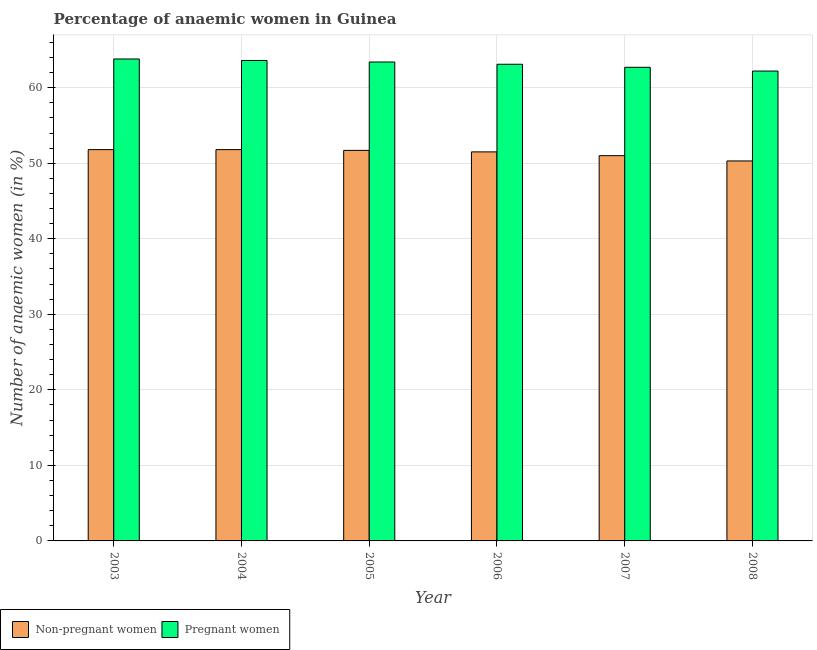Are the number of bars on each tick of the X-axis equal?
Offer a very short reply. Yes. What is the label of the 3rd group of bars from the left?
Keep it short and to the point. 2005. What is the percentage of non-pregnant anaemic women in 2004?
Keep it short and to the point. 51.8. Across all years, what is the maximum percentage of pregnant anaemic women?
Your answer should be very brief. 63.8. Across all years, what is the minimum percentage of non-pregnant anaemic women?
Offer a terse response. 50.3. In which year was the percentage of pregnant anaemic women minimum?
Your answer should be compact. 2008. What is the total percentage of pregnant anaemic women in the graph?
Make the answer very short. 378.8. What is the difference between the percentage of non-pregnant anaemic women in 2004 and that in 2006?
Keep it short and to the point. 0.3. What is the difference between the percentage of non-pregnant anaemic women in 2005 and the percentage of pregnant anaemic women in 2008?
Provide a succinct answer. 1.4. What is the average percentage of non-pregnant anaemic women per year?
Make the answer very short. 51.35. In the year 2006, what is the difference between the percentage of non-pregnant anaemic women and percentage of pregnant anaemic women?
Provide a succinct answer. 0. What is the ratio of the percentage of non-pregnant anaemic women in 2007 to that in 2008?
Your answer should be very brief. 1.01. What is the difference between the highest and the second highest percentage of non-pregnant anaemic women?
Offer a very short reply. 0. What is the difference between the highest and the lowest percentage of non-pregnant anaemic women?
Offer a very short reply. 1.5. What does the 2nd bar from the left in 2007 represents?
Your response must be concise. Pregnant women. What does the 1st bar from the right in 2005 represents?
Ensure brevity in your answer.  Pregnant women. Are all the bars in the graph horizontal?
Provide a short and direct response. No. How many years are there in the graph?
Offer a terse response. 6. What is the difference between two consecutive major ticks on the Y-axis?
Offer a terse response. 10. Does the graph contain grids?
Ensure brevity in your answer.  Yes. Where does the legend appear in the graph?
Give a very brief answer. Bottom left. How many legend labels are there?
Your answer should be compact. 2. What is the title of the graph?
Provide a succinct answer. Percentage of anaemic women in Guinea. What is the label or title of the Y-axis?
Offer a terse response. Number of anaemic women (in %). What is the Number of anaemic women (in %) of Non-pregnant women in 2003?
Keep it short and to the point. 51.8. What is the Number of anaemic women (in %) of Pregnant women in 2003?
Ensure brevity in your answer.  63.8. What is the Number of anaemic women (in %) of Non-pregnant women in 2004?
Provide a succinct answer. 51.8. What is the Number of anaemic women (in %) in Pregnant women in 2004?
Make the answer very short. 63.6. What is the Number of anaemic women (in %) in Non-pregnant women in 2005?
Offer a terse response. 51.7. What is the Number of anaemic women (in %) in Pregnant women in 2005?
Make the answer very short. 63.4. What is the Number of anaemic women (in %) of Non-pregnant women in 2006?
Give a very brief answer. 51.5. What is the Number of anaemic women (in %) of Pregnant women in 2006?
Offer a terse response. 63.1. What is the Number of anaemic women (in %) in Pregnant women in 2007?
Offer a terse response. 62.7. What is the Number of anaemic women (in %) in Non-pregnant women in 2008?
Your answer should be very brief. 50.3. What is the Number of anaemic women (in %) in Pregnant women in 2008?
Provide a short and direct response. 62.2. Across all years, what is the maximum Number of anaemic women (in %) in Non-pregnant women?
Provide a short and direct response. 51.8. Across all years, what is the maximum Number of anaemic women (in %) in Pregnant women?
Your answer should be very brief. 63.8. Across all years, what is the minimum Number of anaemic women (in %) of Non-pregnant women?
Make the answer very short. 50.3. Across all years, what is the minimum Number of anaemic women (in %) of Pregnant women?
Your answer should be very brief. 62.2. What is the total Number of anaemic women (in %) in Non-pregnant women in the graph?
Ensure brevity in your answer.  308.1. What is the total Number of anaemic women (in %) of Pregnant women in the graph?
Ensure brevity in your answer.  378.8. What is the difference between the Number of anaemic women (in %) in Non-pregnant women in 2003 and that in 2004?
Offer a terse response. 0. What is the difference between the Number of anaemic women (in %) of Pregnant women in 2003 and that in 2004?
Provide a short and direct response. 0.2. What is the difference between the Number of anaemic women (in %) in Non-pregnant women in 2003 and that in 2005?
Make the answer very short. 0.1. What is the difference between the Number of anaemic women (in %) of Pregnant women in 2003 and that in 2005?
Your answer should be very brief. 0.4. What is the difference between the Number of anaemic women (in %) of Pregnant women in 2003 and that in 2006?
Your response must be concise. 0.7. What is the difference between the Number of anaemic women (in %) in Pregnant women in 2003 and that in 2007?
Ensure brevity in your answer.  1.1. What is the difference between the Number of anaemic women (in %) of Pregnant women in 2004 and that in 2005?
Keep it short and to the point. 0.2. What is the difference between the Number of anaemic women (in %) in Pregnant women in 2004 and that in 2006?
Your response must be concise. 0.5. What is the difference between the Number of anaemic women (in %) of Non-pregnant women in 2004 and that in 2007?
Offer a terse response. 0.8. What is the difference between the Number of anaemic women (in %) in Non-pregnant women in 2004 and that in 2008?
Keep it short and to the point. 1.5. What is the difference between the Number of anaemic women (in %) in Pregnant women in 2005 and that in 2006?
Ensure brevity in your answer.  0.3. What is the difference between the Number of anaemic women (in %) in Pregnant women in 2005 and that in 2007?
Give a very brief answer. 0.7. What is the difference between the Number of anaemic women (in %) in Non-pregnant women in 2005 and that in 2008?
Ensure brevity in your answer.  1.4. What is the difference between the Number of anaemic women (in %) in Pregnant women in 2005 and that in 2008?
Give a very brief answer. 1.2. What is the difference between the Number of anaemic women (in %) in Non-pregnant women in 2006 and that in 2007?
Your answer should be very brief. 0.5. What is the difference between the Number of anaemic women (in %) in Pregnant women in 2006 and that in 2007?
Keep it short and to the point. 0.4. What is the difference between the Number of anaemic women (in %) in Non-pregnant women in 2007 and that in 2008?
Make the answer very short. 0.7. What is the difference between the Number of anaemic women (in %) in Pregnant women in 2007 and that in 2008?
Your response must be concise. 0.5. What is the difference between the Number of anaemic women (in %) of Non-pregnant women in 2003 and the Number of anaemic women (in %) of Pregnant women in 2006?
Offer a terse response. -11.3. What is the difference between the Number of anaemic women (in %) of Non-pregnant women in 2004 and the Number of anaemic women (in %) of Pregnant women in 2005?
Provide a succinct answer. -11.6. What is the difference between the Number of anaemic women (in %) of Non-pregnant women in 2004 and the Number of anaemic women (in %) of Pregnant women in 2006?
Your answer should be very brief. -11.3. What is the difference between the Number of anaemic women (in %) in Non-pregnant women in 2004 and the Number of anaemic women (in %) in Pregnant women in 2007?
Provide a succinct answer. -10.9. What is the difference between the Number of anaemic women (in %) in Non-pregnant women in 2004 and the Number of anaemic women (in %) in Pregnant women in 2008?
Give a very brief answer. -10.4. What is the difference between the Number of anaemic women (in %) in Non-pregnant women in 2005 and the Number of anaemic women (in %) in Pregnant women in 2007?
Your answer should be very brief. -11. What is the difference between the Number of anaemic women (in %) in Non-pregnant women in 2006 and the Number of anaemic women (in %) in Pregnant women in 2008?
Make the answer very short. -10.7. What is the average Number of anaemic women (in %) of Non-pregnant women per year?
Provide a short and direct response. 51.35. What is the average Number of anaemic women (in %) in Pregnant women per year?
Provide a succinct answer. 63.13. In the year 2004, what is the difference between the Number of anaemic women (in %) in Non-pregnant women and Number of anaemic women (in %) in Pregnant women?
Your answer should be very brief. -11.8. In the year 2006, what is the difference between the Number of anaemic women (in %) of Non-pregnant women and Number of anaemic women (in %) of Pregnant women?
Provide a short and direct response. -11.6. What is the ratio of the Number of anaemic women (in %) in Non-pregnant women in 2003 to that in 2004?
Ensure brevity in your answer.  1. What is the ratio of the Number of anaemic women (in %) of Pregnant women in 2003 to that in 2004?
Keep it short and to the point. 1. What is the ratio of the Number of anaemic women (in %) in Pregnant women in 2003 to that in 2006?
Your answer should be compact. 1.01. What is the ratio of the Number of anaemic women (in %) in Non-pregnant women in 2003 to that in 2007?
Offer a very short reply. 1.02. What is the ratio of the Number of anaemic women (in %) in Pregnant women in 2003 to that in 2007?
Your answer should be compact. 1.02. What is the ratio of the Number of anaemic women (in %) of Non-pregnant women in 2003 to that in 2008?
Make the answer very short. 1.03. What is the ratio of the Number of anaemic women (in %) in Pregnant women in 2003 to that in 2008?
Ensure brevity in your answer.  1.03. What is the ratio of the Number of anaemic women (in %) of Pregnant women in 2004 to that in 2005?
Ensure brevity in your answer.  1. What is the ratio of the Number of anaemic women (in %) of Non-pregnant women in 2004 to that in 2006?
Provide a short and direct response. 1.01. What is the ratio of the Number of anaemic women (in %) of Pregnant women in 2004 to that in 2006?
Provide a short and direct response. 1.01. What is the ratio of the Number of anaemic women (in %) of Non-pregnant women in 2004 to that in 2007?
Keep it short and to the point. 1.02. What is the ratio of the Number of anaemic women (in %) in Pregnant women in 2004 to that in 2007?
Offer a terse response. 1.01. What is the ratio of the Number of anaemic women (in %) of Non-pregnant women in 2004 to that in 2008?
Your answer should be compact. 1.03. What is the ratio of the Number of anaemic women (in %) in Pregnant women in 2004 to that in 2008?
Offer a very short reply. 1.02. What is the ratio of the Number of anaemic women (in %) of Non-pregnant women in 2005 to that in 2006?
Make the answer very short. 1. What is the ratio of the Number of anaemic women (in %) of Pregnant women in 2005 to that in 2006?
Offer a very short reply. 1. What is the ratio of the Number of anaemic women (in %) of Non-pregnant women in 2005 to that in 2007?
Your answer should be compact. 1.01. What is the ratio of the Number of anaemic women (in %) of Pregnant women in 2005 to that in 2007?
Offer a very short reply. 1.01. What is the ratio of the Number of anaemic women (in %) of Non-pregnant women in 2005 to that in 2008?
Offer a terse response. 1.03. What is the ratio of the Number of anaemic women (in %) of Pregnant women in 2005 to that in 2008?
Ensure brevity in your answer.  1.02. What is the ratio of the Number of anaemic women (in %) in Non-pregnant women in 2006 to that in 2007?
Your answer should be very brief. 1.01. What is the ratio of the Number of anaemic women (in %) of Pregnant women in 2006 to that in 2007?
Make the answer very short. 1.01. What is the ratio of the Number of anaemic women (in %) of Non-pregnant women in 2006 to that in 2008?
Provide a succinct answer. 1.02. What is the ratio of the Number of anaemic women (in %) of Pregnant women in 2006 to that in 2008?
Provide a succinct answer. 1.01. What is the ratio of the Number of anaemic women (in %) in Non-pregnant women in 2007 to that in 2008?
Provide a short and direct response. 1.01. 